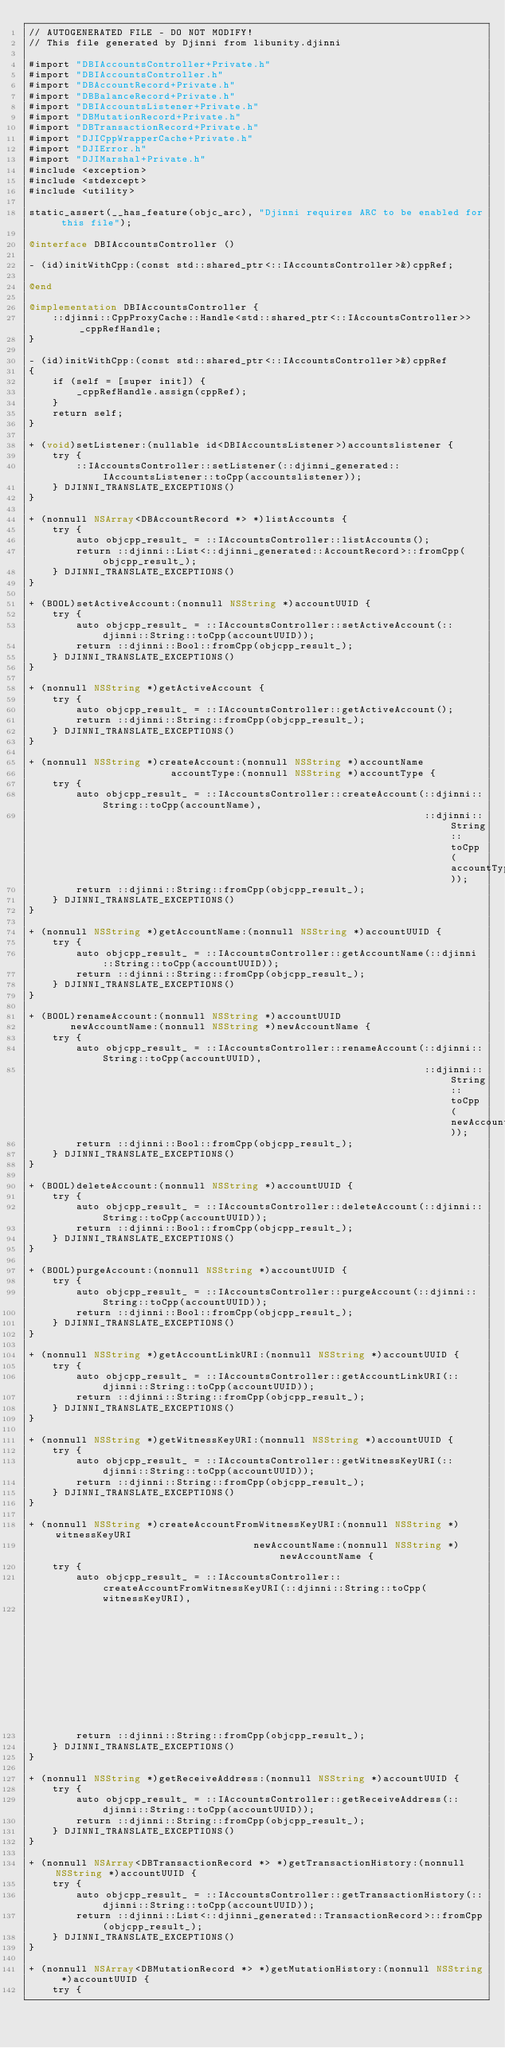Convert code to text. <code><loc_0><loc_0><loc_500><loc_500><_ObjectiveC_>// AUTOGENERATED FILE - DO NOT MODIFY!
// This file generated by Djinni from libunity.djinni

#import "DBIAccountsController+Private.h"
#import "DBIAccountsController.h"
#import "DBAccountRecord+Private.h"
#import "DBBalanceRecord+Private.h"
#import "DBIAccountsListener+Private.h"
#import "DBMutationRecord+Private.h"
#import "DBTransactionRecord+Private.h"
#import "DJICppWrapperCache+Private.h"
#import "DJIError.h"
#import "DJIMarshal+Private.h"
#include <exception>
#include <stdexcept>
#include <utility>

static_assert(__has_feature(objc_arc), "Djinni requires ARC to be enabled for this file");

@interface DBIAccountsController ()

- (id)initWithCpp:(const std::shared_ptr<::IAccountsController>&)cppRef;

@end

@implementation DBIAccountsController {
    ::djinni::CppProxyCache::Handle<std::shared_ptr<::IAccountsController>> _cppRefHandle;
}

- (id)initWithCpp:(const std::shared_ptr<::IAccountsController>&)cppRef
{
    if (self = [super init]) {
        _cppRefHandle.assign(cppRef);
    }
    return self;
}

+ (void)setListener:(nullable id<DBIAccountsListener>)accountslistener {
    try {
        ::IAccountsController::setListener(::djinni_generated::IAccountsListener::toCpp(accountslistener));
    } DJINNI_TRANSLATE_EXCEPTIONS()
}

+ (nonnull NSArray<DBAccountRecord *> *)listAccounts {
    try {
        auto objcpp_result_ = ::IAccountsController::listAccounts();
        return ::djinni::List<::djinni_generated::AccountRecord>::fromCpp(objcpp_result_);
    } DJINNI_TRANSLATE_EXCEPTIONS()
}

+ (BOOL)setActiveAccount:(nonnull NSString *)accountUUID {
    try {
        auto objcpp_result_ = ::IAccountsController::setActiveAccount(::djinni::String::toCpp(accountUUID));
        return ::djinni::Bool::fromCpp(objcpp_result_);
    } DJINNI_TRANSLATE_EXCEPTIONS()
}

+ (nonnull NSString *)getActiveAccount {
    try {
        auto objcpp_result_ = ::IAccountsController::getActiveAccount();
        return ::djinni::String::fromCpp(objcpp_result_);
    } DJINNI_TRANSLATE_EXCEPTIONS()
}

+ (nonnull NSString *)createAccount:(nonnull NSString *)accountName
                        accountType:(nonnull NSString *)accountType {
    try {
        auto objcpp_result_ = ::IAccountsController::createAccount(::djinni::String::toCpp(accountName),
                                                                   ::djinni::String::toCpp(accountType));
        return ::djinni::String::fromCpp(objcpp_result_);
    } DJINNI_TRANSLATE_EXCEPTIONS()
}

+ (nonnull NSString *)getAccountName:(nonnull NSString *)accountUUID {
    try {
        auto objcpp_result_ = ::IAccountsController::getAccountName(::djinni::String::toCpp(accountUUID));
        return ::djinni::String::fromCpp(objcpp_result_);
    } DJINNI_TRANSLATE_EXCEPTIONS()
}

+ (BOOL)renameAccount:(nonnull NSString *)accountUUID
       newAccountName:(nonnull NSString *)newAccountName {
    try {
        auto objcpp_result_ = ::IAccountsController::renameAccount(::djinni::String::toCpp(accountUUID),
                                                                   ::djinni::String::toCpp(newAccountName));
        return ::djinni::Bool::fromCpp(objcpp_result_);
    } DJINNI_TRANSLATE_EXCEPTIONS()
}

+ (BOOL)deleteAccount:(nonnull NSString *)accountUUID {
    try {
        auto objcpp_result_ = ::IAccountsController::deleteAccount(::djinni::String::toCpp(accountUUID));
        return ::djinni::Bool::fromCpp(objcpp_result_);
    } DJINNI_TRANSLATE_EXCEPTIONS()
}

+ (BOOL)purgeAccount:(nonnull NSString *)accountUUID {
    try {
        auto objcpp_result_ = ::IAccountsController::purgeAccount(::djinni::String::toCpp(accountUUID));
        return ::djinni::Bool::fromCpp(objcpp_result_);
    } DJINNI_TRANSLATE_EXCEPTIONS()
}

+ (nonnull NSString *)getAccountLinkURI:(nonnull NSString *)accountUUID {
    try {
        auto objcpp_result_ = ::IAccountsController::getAccountLinkURI(::djinni::String::toCpp(accountUUID));
        return ::djinni::String::fromCpp(objcpp_result_);
    } DJINNI_TRANSLATE_EXCEPTIONS()
}

+ (nonnull NSString *)getWitnessKeyURI:(nonnull NSString *)accountUUID {
    try {
        auto objcpp_result_ = ::IAccountsController::getWitnessKeyURI(::djinni::String::toCpp(accountUUID));
        return ::djinni::String::fromCpp(objcpp_result_);
    } DJINNI_TRANSLATE_EXCEPTIONS()
}

+ (nonnull NSString *)createAccountFromWitnessKeyURI:(nonnull NSString *)witnessKeyURI
                                      newAccountName:(nonnull NSString *)newAccountName {
    try {
        auto objcpp_result_ = ::IAccountsController::createAccountFromWitnessKeyURI(::djinni::String::toCpp(witnessKeyURI),
                                                                                    ::djinni::String::toCpp(newAccountName));
        return ::djinni::String::fromCpp(objcpp_result_);
    } DJINNI_TRANSLATE_EXCEPTIONS()
}

+ (nonnull NSString *)getReceiveAddress:(nonnull NSString *)accountUUID {
    try {
        auto objcpp_result_ = ::IAccountsController::getReceiveAddress(::djinni::String::toCpp(accountUUID));
        return ::djinni::String::fromCpp(objcpp_result_);
    } DJINNI_TRANSLATE_EXCEPTIONS()
}

+ (nonnull NSArray<DBTransactionRecord *> *)getTransactionHistory:(nonnull NSString *)accountUUID {
    try {
        auto objcpp_result_ = ::IAccountsController::getTransactionHistory(::djinni::String::toCpp(accountUUID));
        return ::djinni::List<::djinni_generated::TransactionRecord>::fromCpp(objcpp_result_);
    } DJINNI_TRANSLATE_EXCEPTIONS()
}

+ (nonnull NSArray<DBMutationRecord *> *)getMutationHistory:(nonnull NSString *)accountUUID {
    try {</code> 